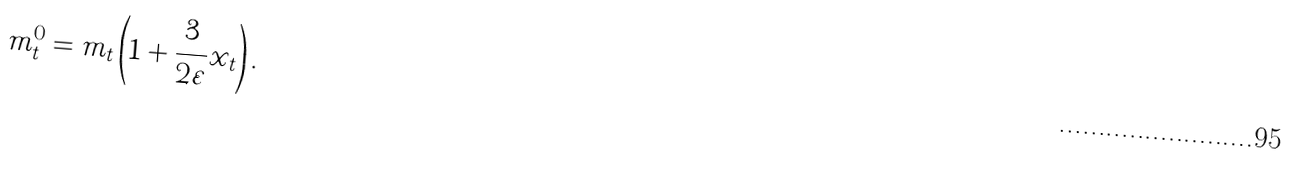<formula> <loc_0><loc_0><loc_500><loc_500>m _ { t } ^ { 0 } = m _ { t } \left ( 1 + \frac { 3 } { 2 \varepsilon } x _ { t } \right ) .</formula> 